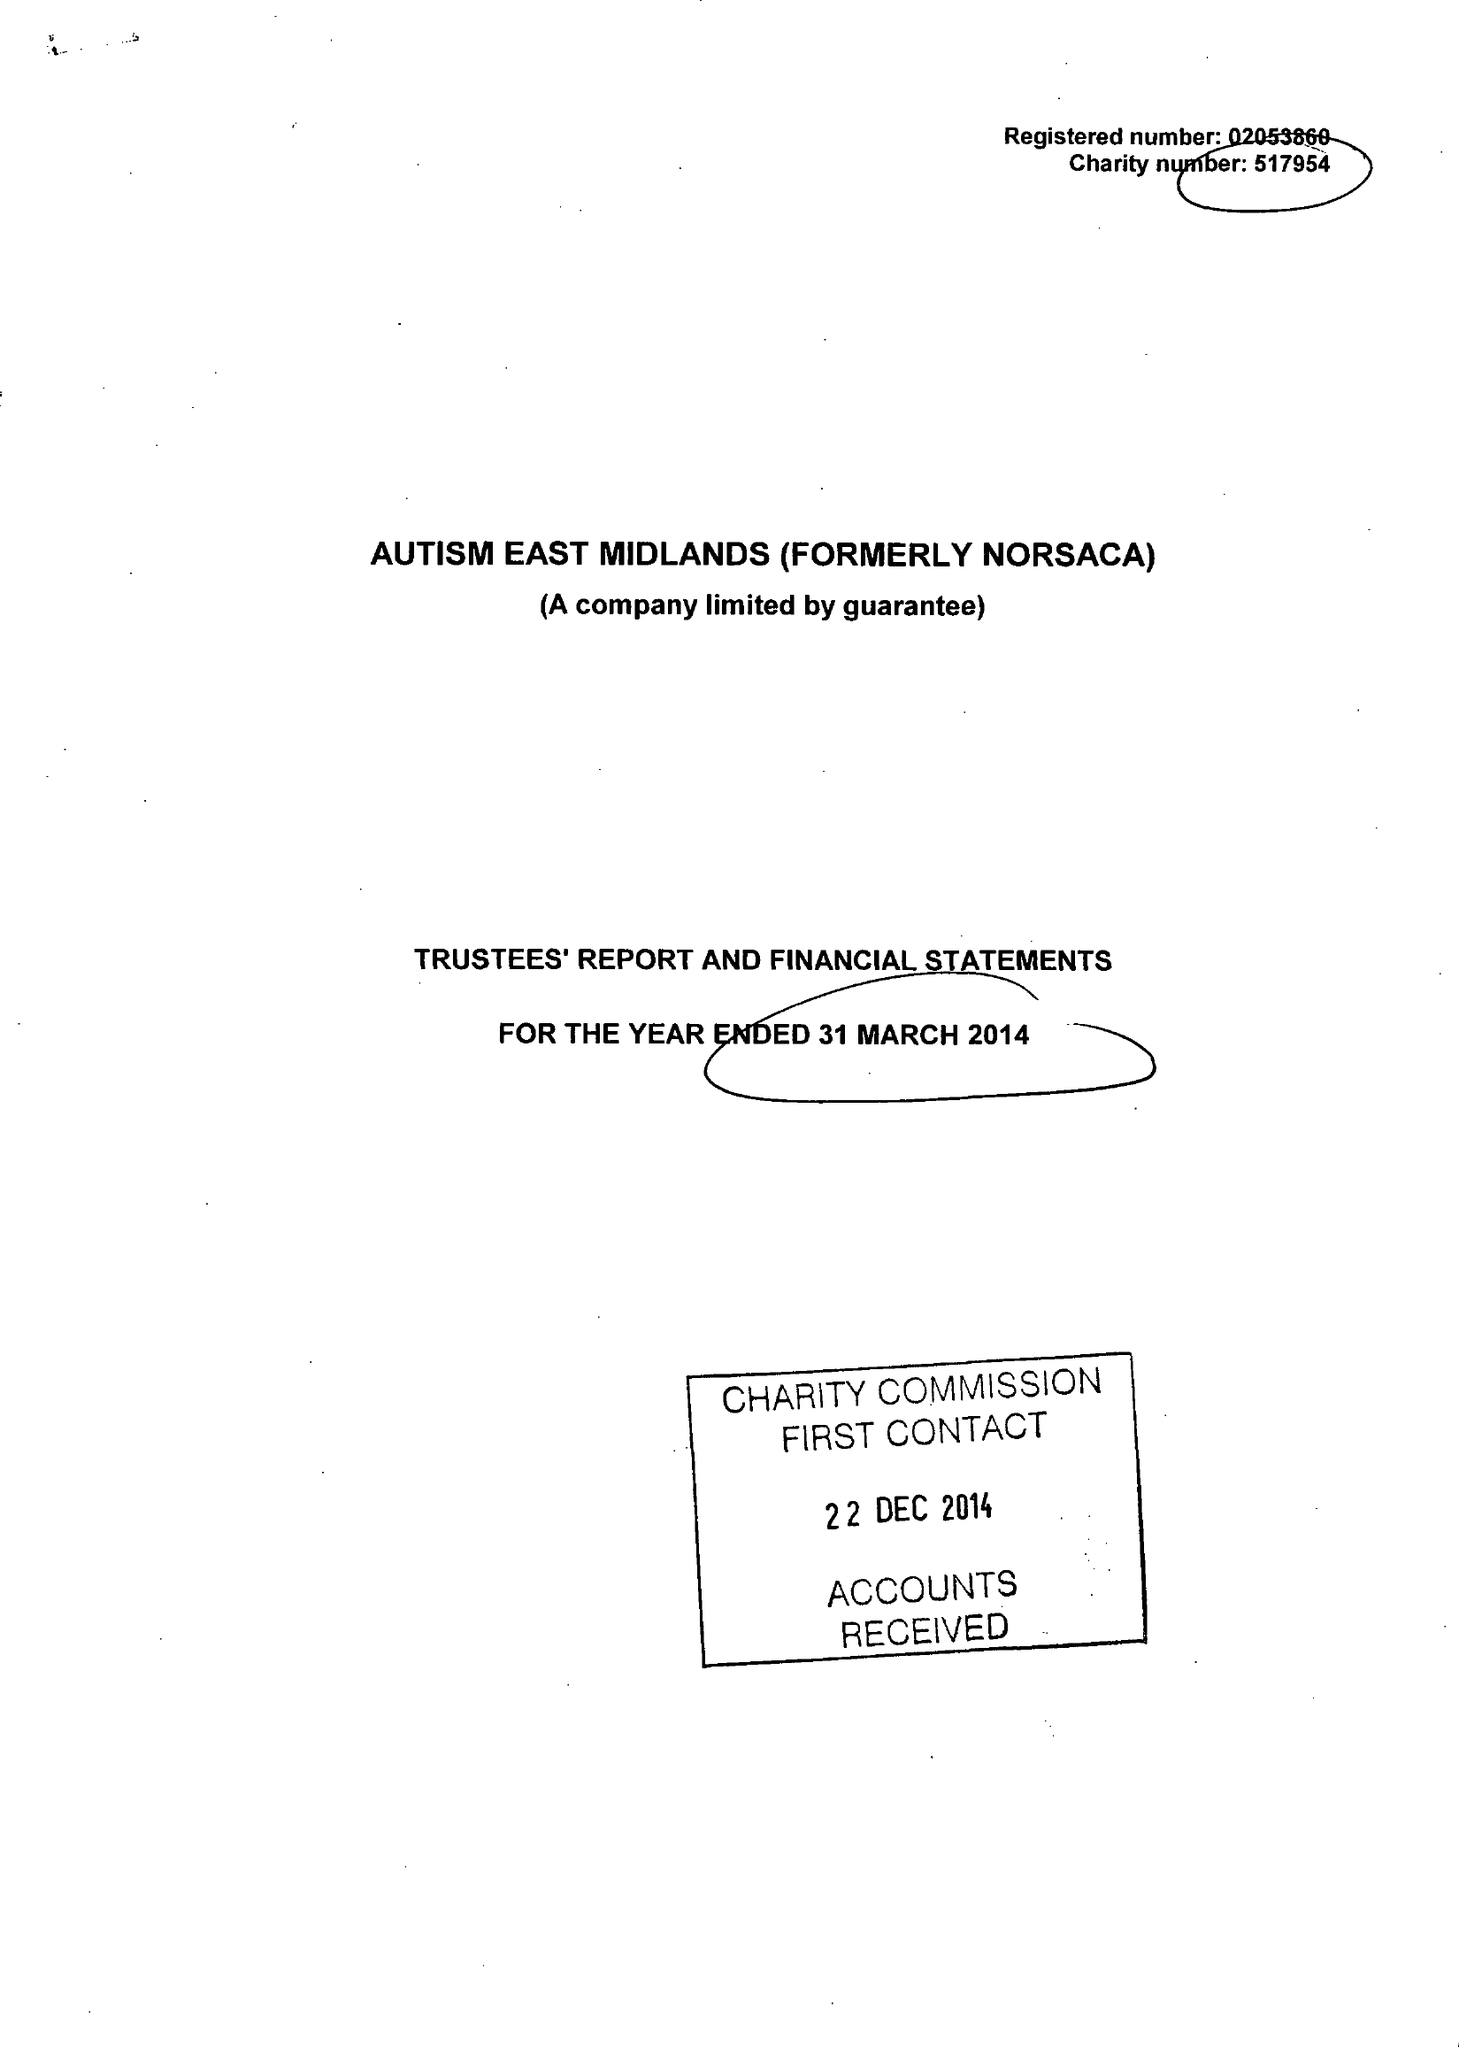What is the value for the charity_name?
Answer the question using a single word or phrase. Autism East Midlands 